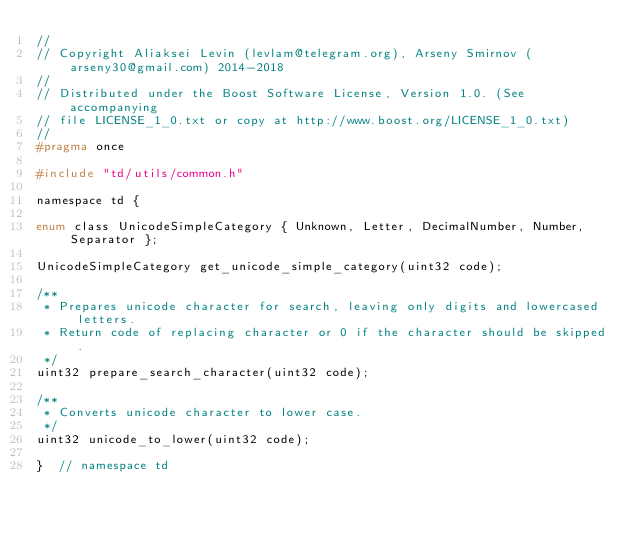Convert code to text. <code><loc_0><loc_0><loc_500><loc_500><_C_>//
// Copyright Aliaksei Levin (levlam@telegram.org), Arseny Smirnov (arseny30@gmail.com) 2014-2018
//
// Distributed under the Boost Software License, Version 1.0. (See accompanying
// file LICENSE_1_0.txt or copy at http://www.boost.org/LICENSE_1_0.txt)
//
#pragma once

#include "td/utils/common.h"

namespace td {

enum class UnicodeSimpleCategory { Unknown, Letter, DecimalNumber, Number, Separator };

UnicodeSimpleCategory get_unicode_simple_category(uint32 code);

/**
 * Prepares unicode character for search, leaving only digits and lowercased letters.
 * Return code of replacing character or 0 if the character should be skipped.
 */
uint32 prepare_search_character(uint32 code);

/**
 * Converts unicode character to lower case.
 */
uint32 unicode_to_lower(uint32 code);

}  // namespace td
</code> 